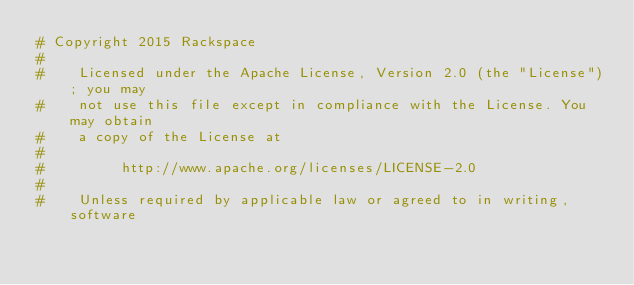Convert code to text. <code><loc_0><loc_0><loc_500><loc_500><_Python_># Copyright 2015 Rackspace
#
#    Licensed under the Apache License, Version 2.0 (the "License"); you may
#    not use this file except in compliance with the License. You may obtain
#    a copy of the License at
#
#         http://www.apache.org/licenses/LICENSE-2.0
#
#    Unless required by applicable law or agreed to in writing, software</code> 